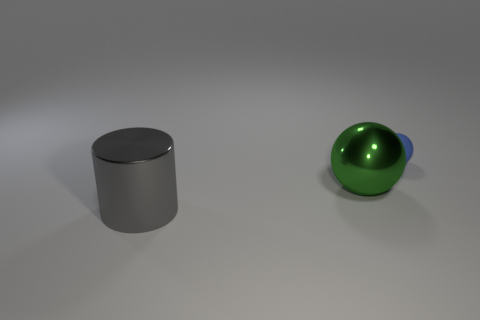What number of large things are either gray metal objects or metal things?
Provide a short and direct response. 2. What number of objects are large metallic things left of the large green shiny object or large metal things behind the large gray shiny thing?
Make the answer very short. 2. Is the number of blue rubber objects less than the number of big cyan spheres?
Ensure brevity in your answer.  No. What shape is the other thing that is the same size as the gray metallic object?
Make the answer very short. Sphere. How many other things are the same color as the small thing?
Your response must be concise. 0. What number of large purple metal balls are there?
Your response must be concise. 0. How many objects are behind the metal cylinder and to the left of the tiny blue ball?
Ensure brevity in your answer.  1. What is the material of the blue sphere?
Provide a short and direct response. Rubber. Are any cyan blocks visible?
Provide a short and direct response. No. There is a sphere that is in front of the small rubber thing; what is its color?
Your answer should be compact. Green. 